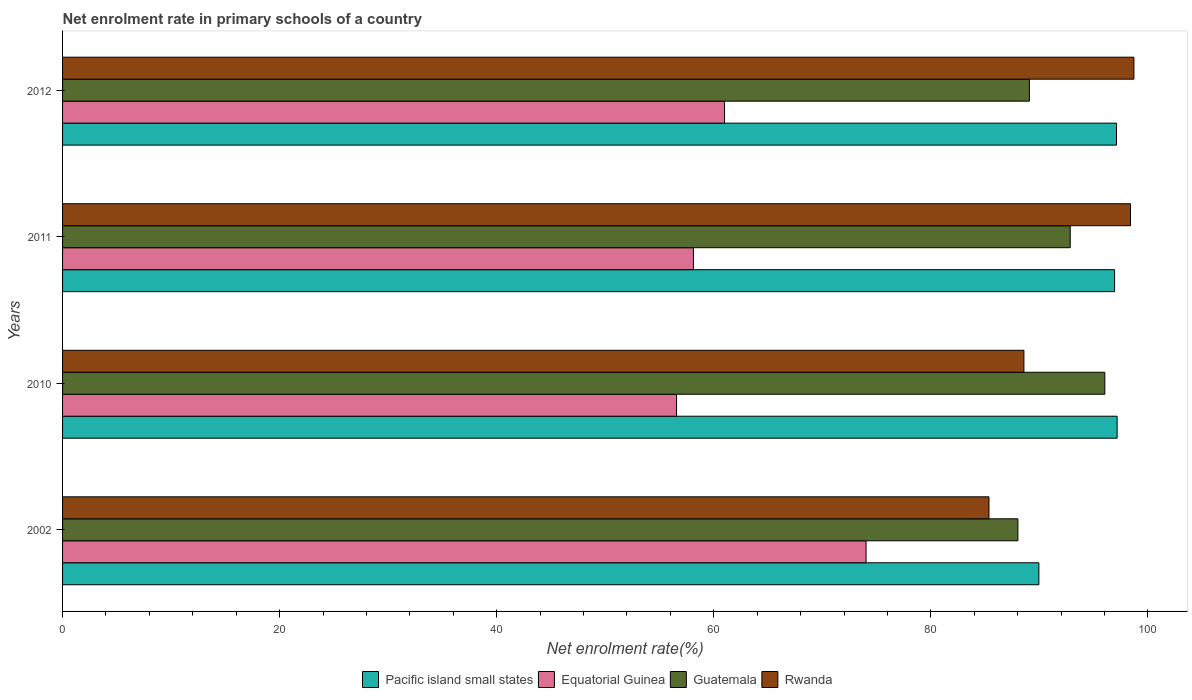How many different coloured bars are there?
Ensure brevity in your answer.  4. How many groups of bars are there?
Make the answer very short. 4. Are the number of bars per tick equal to the number of legend labels?
Your answer should be very brief. Yes. Are the number of bars on each tick of the Y-axis equal?
Your answer should be very brief. Yes. How many bars are there on the 4th tick from the bottom?
Provide a succinct answer. 4. What is the net enrolment rate in primary schools in Equatorial Guinea in 2010?
Keep it short and to the point. 56.57. Across all years, what is the maximum net enrolment rate in primary schools in Rwanda?
Give a very brief answer. 98.71. Across all years, what is the minimum net enrolment rate in primary schools in Pacific island small states?
Offer a terse response. 89.95. In which year was the net enrolment rate in primary schools in Equatorial Guinea maximum?
Offer a very short reply. 2002. What is the total net enrolment rate in primary schools in Pacific island small states in the graph?
Make the answer very short. 381.14. What is the difference between the net enrolment rate in primary schools in Pacific island small states in 2010 and that in 2012?
Offer a terse response. 0.06. What is the difference between the net enrolment rate in primary schools in Equatorial Guinea in 2010 and the net enrolment rate in primary schools in Rwanda in 2012?
Ensure brevity in your answer.  -42.14. What is the average net enrolment rate in primary schools in Rwanda per year?
Provide a succinct answer. 92.76. In the year 2002, what is the difference between the net enrolment rate in primary schools in Pacific island small states and net enrolment rate in primary schools in Guatemala?
Keep it short and to the point. 1.93. What is the ratio of the net enrolment rate in primary schools in Equatorial Guinea in 2002 to that in 2010?
Offer a very short reply. 1.31. Is the net enrolment rate in primary schools in Pacific island small states in 2011 less than that in 2012?
Ensure brevity in your answer.  Yes. What is the difference between the highest and the second highest net enrolment rate in primary schools in Rwanda?
Keep it short and to the point. 0.31. What is the difference between the highest and the lowest net enrolment rate in primary schools in Equatorial Guinea?
Offer a very short reply. 17.46. In how many years, is the net enrolment rate in primary schools in Equatorial Guinea greater than the average net enrolment rate in primary schools in Equatorial Guinea taken over all years?
Make the answer very short. 1. Is the sum of the net enrolment rate in primary schools in Guatemala in 2011 and 2012 greater than the maximum net enrolment rate in primary schools in Equatorial Guinea across all years?
Your answer should be very brief. Yes. What does the 4th bar from the top in 2010 represents?
Ensure brevity in your answer.  Pacific island small states. What does the 4th bar from the bottom in 2010 represents?
Offer a terse response. Rwanda. Is it the case that in every year, the sum of the net enrolment rate in primary schools in Equatorial Guinea and net enrolment rate in primary schools in Pacific island small states is greater than the net enrolment rate in primary schools in Guatemala?
Keep it short and to the point. Yes. How many bars are there?
Provide a short and direct response. 16. Are all the bars in the graph horizontal?
Provide a succinct answer. Yes. How many years are there in the graph?
Provide a succinct answer. 4. What is the difference between two consecutive major ticks on the X-axis?
Your response must be concise. 20. Where does the legend appear in the graph?
Offer a very short reply. Bottom center. How are the legend labels stacked?
Make the answer very short. Horizontal. What is the title of the graph?
Offer a very short reply. Net enrolment rate in primary schools of a country. What is the label or title of the X-axis?
Your answer should be very brief. Net enrolment rate(%). What is the Net enrolment rate(%) in Pacific island small states in 2002?
Your response must be concise. 89.95. What is the Net enrolment rate(%) of Equatorial Guinea in 2002?
Your response must be concise. 74.03. What is the Net enrolment rate(%) of Guatemala in 2002?
Give a very brief answer. 88.02. What is the Net enrolment rate(%) of Rwanda in 2002?
Your response must be concise. 85.35. What is the Net enrolment rate(%) of Pacific island small states in 2010?
Ensure brevity in your answer.  97.16. What is the Net enrolment rate(%) in Equatorial Guinea in 2010?
Your answer should be very brief. 56.57. What is the Net enrolment rate(%) in Guatemala in 2010?
Keep it short and to the point. 96.03. What is the Net enrolment rate(%) of Rwanda in 2010?
Your answer should be very brief. 88.57. What is the Net enrolment rate(%) of Pacific island small states in 2011?
Keep it short and to the point. 96.93. What is the Net enrolment rate(%) in Equatorial Guinea in 2011?
Provide a short and direct response. 58.12. What is the Net enrolment rate(%) in Guatemala in 2011?
Give a very brief answer. 92.84. What is the Net enrolment rate(%) of Rwanda in 2011?
Make the answer very short. 98.39. What is the Net enrolment rate(%) of Pacific island small states in 2012?
Offer a terse response. 97.1. What is the Net enrolment rate(%) of Equatorial Guinea in 2012?
Ensure brevity in your answer.  60.99. What is the Net enrolment rate(%) in Guatemala in 2012?
Offer a very short reply. 89.08. What is the Net enrolment rate(%) of Rwanda in 2012?
Your answer should be compact. 98.71. Across all years, what is the maximum Net enrolment rate(%) in Pacific island small states?
Make the answer very short. 97.16. Across all years, what is the maximum Net enrolment rate(%) of Equatorial Guinea?
Provide a short and direct response. 74.03. Across all years, what is the maximum Net enrolment rate(%) of Guatemala?
Offer a terse response. 96.03. Across all years, what is the maximum Net enrolment rate(%) of Rwanda?
Your answer should be very brief. 98.71. Across all years, what is the minimum Net enrolment rate(%) in Pacific island small states?
Your answer should be very brief. 89.95. Across all years, what is the minimum Net enrolment rate(%) of Equatorial Guinea?
Offer a terse response. 56.57. Across all years, what is the minimum Net enrolment rate(%) of Guatemala?
Offer a terse response. 88.02. Across all years, what is the minimum Net enrolment rate(%) in Rwanda?
Provide a short and direct response. 85.35. What is the total Net enrolment rate(%) in Pacific island small states in the graph?
Offer a very short reply. 381.14. What is the total Net enrolment rate(%) in Equatorial Guinea in the graph?
Provide a succinct answer. 249.71. What is the total Net enrolment rate(%) of Guatemala in the graph?
Offer a very short reply. 365.96. What is the total Net enrolment rate(%) of Rwanda in the graph?
Ensure brevity in your answer.  371.03. What is the difference between the Net enrolment rate(%) of Pacific island small states in 2002 and that in 2010?
Keep it short and to the point. -7.21. What is the difference between the Net enrolment rate(%) of Equatorial Guinea in 2002 and that in 2010?
Provide a short and direct response. 17.46. What is the difference between the Net enrolment rate(%) in Guatemala in 2002 and that in 2010?
Your answer should be very brief. -8.01. What is the difference between the Net enrolment rate(%) of Rwanda in 2002 and that in 2010?
Offer a terse response. -3.22. What is the difference between the Net enrolment rate(%) of Pacific island small states in 2002 and that in 2011?
Your answer should be compact. -6.98. What is the difference between the Net enrolment rate(%) in Equatorial Guinea in 2002 and that in 2011?
Give a very brief answer. 15.91. What is the difference between the Net enrolment rate(%) in Guatemala in 2002 and that in 2011?
Your answer should be very brief. -4.82. What is the difference between the Net enrolment rate(%) of Rwanda in 2002 and that in 2011?
Keep it short and to the point. -13.04. What is the difference between the Net enrolment rate(%) in Pacific island small states in 2002 and that in 2012?
Provide a succinct answer. -7.15. What is the difference between the Net enrolment rate(%) in Equatorial Guinea in 2002 and that in 2012?
Your response must be concise. 13.04. What is the difference between the Net enrolment rate(%) of Guatemala in 2002 and that in 2012?
Offer a very short reply. -1.06. What is the difference between the Net enrolment rate(%) in Rwanda in 2002 and that in 2012?
Your response must be concise. -13.35. What is the difference between the Net enrolment rate(%) in Pacific island small states in 2010 and that in 2011?
Make the answer very short. 0.23. What is the difference between the Net enrolment rate(%) of Equatorial Guinea in 2010 and that in 2011?
Provide a succinct answer. -1.55. What is the difference between the Net enrolment rate(%) in Guatemala in 2010 and that in 2011?
Offer a very short reply. 3.19. What is the difference between the Net enrolment rate(%) of Rwanda in 2010 and that in 2011?
Give a very brief answer. -9.82. What is the difference between the Net enrolment rate(%) of Pacific island small states in 2010 and that in 2012?
Provide a succinct answer. 0.06. What is the difference between the Net enrolment rate(%) in Equatorial Guinea in 2010 and that in 2012?
Ensure brevity in your answer.  -4.42. What is the difference between the Net enrolment rate(%) of Guatemala in 2010 and that in 2012?
Your answer should be very brief. 6.95. What is the difference between the Net enrolment rate(%) in Rwanda in 2010 and that in 2012?
Keep it short and to the point. -10.14. What is the difference between the Net enrolment rate(%) in Pacific island small states in 2011 and that in 2012?
Your answer should be compact. -0.18. What is the difference between the Net enrolment rate(%) in Equatorial Guinea in 2011 and that in 2012?
Offer a very short reply. -2.87. What is the difference between the Net enrolment rate(%) of Guatemala in 2011 and that in 2012?
Make the answer very short. 3.76. What is the difference between the Net enrolment rate(%) in Rwanda in 2011 and that in 2012?
Your answer should be very brief. -0.31. What is the difference between the Net enrolment rate(%) of Pacific island small states in 2002 and the Net enrolment rate(%) of Equatorial Guinea in 2010?
Your response must be concise. 33.38. What is the difference between the Net enrolment rate(%) in Pacific island small states in 2002 and the Net enrolment rate(%) in Guatemala in 2010?
Provide a short and direct response. -6.07. What is the difference between the Net enrolment rate(%) in Pacific island small states in 2002 and the Net enrolment rate(%) in Rwanda in 2010?
Ensure brevity in your answer.  1.38. What is the difference between the Net enrolment rate(%) in Equatorial Guinea in 2002 and the Net enrolment rate(%) in Guatemala in 2010?
Provide a succinct answer. -22. What is the difference between the Net enrolment rate(%) in Equatorial Guinea in 2002 and the Net enrolment rate(%) in Rwanda in 2010?
Make the answer very short. -14.54. What is the difference between the Net enrolment rate(%) in Guatemala in 2002 and the Net enrolment rate(%) in Rwanda in 2010?
Make the answer very short. -0.55. What is the difference between the Net enrolment rate(%) in Pacific island small states in 2002 and the Net enrolment rate(%) in Equatorial Guinea in 2011?
Your answer should be compact. 31.83. What is the difference between the Net enrolment rate(%) in Pacific island small states in 2002 and the Net enrolment rate(%) in Guatemala in 2011?
Your response must be concise. -2.89. What is the difference between the Net enrolment rate(%) of Pacific island small states in 2002 and the Net enrolment rate(%) of Rwanda in 2011?
Provide a short and direct response. -8.44. What is the difference between the Net enrolment rate(%) of Equatorial Guinea in 2002 and the Net enrolment rate(%) of Guatemala in 2011?
Offer a very short reply. -18.81. What is the difference between the Net enrolment rate(%) of Equatorial Guinea in 2002 and the Net enrolment rate(%) of Rwanda in 2011?
Your answer should be compact. -24.36. What is the difference between the Net enrolment rate(%) in Guatemala in 2002 and the Net enrolment rate(%) in Rwanda in 2011?
Your answer should be very brief. -10.38. What is the difference between the Net enrolment rate(%) in Pacific island small states in 2002 and the Net enrolment rate(%) in Equatorial Guinea in 2012?
Ensure brevity in your answer.  28.96. What is the difference between the Net enrolment rate(%) of Pacific island small states in 2002 and the Net enrolment rate(%) of Guatemala in 2012?
Offer a terse response. 0.87. What is the difference between the Net enrolment rate(%) in Pacific island small states in 2002 and the Net enrolment rate(%) in Rwanda in 2012?
Your answer should be very brief. -8.76. What is the difference between the Net enrolment rate(%) in Equatorial Guinea in 2002 and the Net enrolment rate(%) in Guatemala in 2012?
Make the answer very short. -15.05. What is the difference between the Net enrolment rate(%) in Equatorial Guinea in 2002 and the Net enrolment rate(%) in Rwanda in 2012?
Your answer should be very brief. -24.68. What is the difference between the Net enrolment rate(%) in Guatemala in 2002 and the Net enrolment rate(%) in Rwanda in 2012?
Your response must be concise. -10.69. What is the difference between the Net enrolment rate(%) in Pacific island small states in 2010 and the Net enrolment rate(%) in Equatorial Guinea in 2011?
Offer a very short reply. 39.04. What is the difference between the Net enrolment rate(%) in Pacific island small states in 2010 and the Net enrolment rate(%) in Guatemala in 2011?
Offer a very short reply. 4.32. What is the difference between the Net enrolment rate(%) of Pacific island small states in 2010 and the Net enrolment rate(%) of Rwanda in 2011?
Give a very brief answer. -1.23. What is the difference between the Net enrolment rate(%) in Equatorial Guinea in 2010 and the Net enrolment rate(%) in Guatemala in 2011?
Your answer should be compact. -36.27. What is the difference between the Net enrolment rate(%) in Equatorial Guinea in 2010 and the Net enrolment rate(%) in Rwanda in 2011?
Keep it short and to the point. -41.83. What is the difference between the Net enrolment rate(%) in Guatemala in 2010 and the Net enrolment rate(%) in Rwanda in 2011?
Your answer should be compact. -2.37. What is the difference between the Net enrolment rate(%) in Pacific island small states in 2010 and the Net enrolment rate(%) in Equatorial Guinea in 2012?
Ensure brevity in your answer.  36.17. What is the difference between the Net enrolment rate(%) in Pacific island small states in 2010 and the Net enrolment rate(%) in Guatemala in 2012?
Offer a very short reply. 8.08. What is the difference between the Net enrolment rate(%) in Pacific island small states in 2010 and the Net enrolment rate(%) in Rwanda in 2012?
Your answer should be very brief. -1.55. What is the difference between the Net enrolment rate(%) in Equatorial Guinea in 2010 and the Net enrolment rate(%) in Guatemala in 2012?
Your response must be concise. -32.51. What is the difference between the Net enrolment rate(%) in Equatorial Guinea in 2010 and the Net enrolment rate(%) in Rwanda in 2012?
Make the answer very short. -42.14. What is the difference between the Net enrolment rate(%) in Guatemala in 2010 and the Net enrolment rate(%) in Rwanda in 2012?
Your response must be concise. -2.68. What is the difference between the Net enrolment rate(%) in Pacific island small states in 2011 and the Net enrolment rate(%) in Equatorial Guinea in 2012?
Keep it short and to the point. 35.94. What is the difference between the Net enrolment rate(%) in Pacific island small states in 2011 and the Net enrolment rate(%) in Guatemala in 2012?
Make the answer very short. 7.85. What is the difference between the Net enrolment rate(%) in Pacific island small states in 2011 and the Net enrolment rate(%) in Rwanda in 2012?
Your response must be concise. -1.78. What is the difference between the Net enrolment rate(%) of Equatorial Guinea in 2011 and the Net enrolment rate(%) of Guatemala in 2012?
Keep it short and to the point. -30.96. What is the difference between the Net enrolment rate(%) in Equatorial Guinea in 2011 and the Net enrolment rate(%) in Rwanda in 2012?
Keep it short and to the point. -40.59. What is the difference between the Net enrolment rate(%) of Guatemala in 2011 and the Net enrolment rate(%) of Rwanda in 2012?
Keep it short and to the point. -5.87. What is the average Net enrolment rate(%) in Pacific island small states per year?
Keep it short and to the point. 95.29. What is the average Net enrolment rate(%) of Equatorial Guinea per year?
Give a very brief answer. 62.43. What is the average Net enrolment rate(%) in Guatemala per year?
Make the answer very short. 91.49. What is the average Net enrolment rate(%) of Rwanda per year?
Your answer should be very brief. 92.76. In the year 2002, what is the difference between the Net enrolment rate(%) in Pacific island small states and Net enrolment rate(%) in Equatorial Guinea?
Offer a terse response. 15.92. In the year 2002, what is the difference between the Net enrolment rate(%) of Pacific island small states and Net enrolment rate(%) of Guatemala?
Your answer should be compact. 1.93. In the year 2002, what is the difference between the Net enrolment rate(%) of Pacific island small states and Net enrolment rate(%) of Rwanda?
Make the answer very short. 4.6. In the year 2002, what is the difference between the Net enrolment rate(%) in Equatorial Guinea and Net enrolment rate(%) in Guatemala?
Provide a short and direct response. -13.99. In the year 2002, what is the difference between the Net enrolment rate(%) in Equatorial Guinea and Net enrolment rate(%) in Rwanda?
Offer a terse response. -11.32. In the year 2002, what is the difference between the Net enrolment rate(%) in Guatemala and Net enrolment rate(%) in Rwanda?
Make the answer very short. 2.66. In the year 2010, what is the difference between the Net enrolment rate(%) in Pacific island small states and Net enrolment rate(%) in Equatorial Guinea?
Offer a terse response. 40.59. In the year 2010, what is the difference between the Net enrolment rate(%) of Pacific island small states and Net enrolment rate(%) of Guatemala?
Your answer should be very brief. 1.13. In the year 2010, what is the difference between the Net enrolment rate(%) of Pacific island small states and Net enrolment rate(%) of Rwanda?
Give a very brief answer. 8.59. In the year 2010, what is the difference between the Net enrolment rate(%) in Equatorial Guinea and Net enrolment rate(%) in Guatemala?
Offer a terse response. -39.46. In the year 2010, what is the difference between the Net enrolment rate(%) of Equatorial Guinea and Net enrolment rate(%) of Rwanda?
Provide a succinct answer. -32. In the year 2010, what is the difference between the Net enrolment rate(%) in Guatemala and Net enrolment rate(%) in Rwanda?
Ensure brevity in your answer.  7.45. In the year 2011, what is the difference between the Net enrolment rate(%) in Pacific island small states and Net enrolment rate(%) in Equatorial Guinea?
Make the answer very short. 38.81. In the year 2011, what is the difference between the Net enrolment rate(%) of Pacific island small states and Net enrolment rate(%) of Guatemala?
Your response must be concise. 4.09. In the year 2011, what is the difference between the Net enrolment rate(%) of Pacific island small states and Net enrolment rate(%) of Rwanda?
Make the answer very short. -1.47. In the year 2011, what is the difference between the Net enrolment rate(%) in Equatorial Guinea and Net enrolment rate(%) in Guatemala?
Ensure brevity in your answer.  -34.72. In the year 2011, what is the difference between the Net enrolment rate(%) in Equatorial Guinea and Net enrolment rate(%) in Rwanda?
Provide a short and direct response. -40.27. In the year 2011, what is the difference between the Net enrolment rate(%) of Guatemala and Net enrolment rate(%) of Rwanda?
Make the answer very short. -5.55. In the year 2012, what is the difference between the Net enrolment rate(%) in Pacific island small states and Net enrolment rate(%) in Equatorial Guinea?
Your response must be concise. 36.11. In the year 2012, what is the difference between the Net enrolment rate(%) in Pacific island small states and Net enrolment rate(%) in Guatemala?
Your answer should be compact. 8.03. In the year 2012, what is the difference between the Net enrolment rate(%) in Pacific island small states and Net enrolment rate(%) in Rwanda?
Offer a terse response. -1.61. In the year 2012, what is the difference between the Net enrolment rate(%) of Equatorial Guinea and Net enrolment rate(%) of Guatemala?
Provide a succinct answer. -28.09. In the year 2012, what is the difference between the Net enrolment rate(%) in Equatorial Guinea and Net enrolment rate(%) in Rwanda?
Your response must be concise. -37.72. In the year 2012, what is the difference between the Net enrolment rate(%) in Guatemala and Net enrolment rate(%) in Rwanda?
Offer a very short reply. -9.63. What is the ratio of the Net enrolment rate(%) in Pacific island small states in 2002 to that in 2010?
Ensure brevity in your answer.  0.93. What is the ratio of the Net enrolment rate(%) of Equatorial Guinea in 2002 to that in 2010?
Ensure brevity in your answer.  1.31. What is the ratio of the Net enrolment rate(%) in Guatemala in 2002 to that in 2010?
Offer a terse response. 0.92. What is the ratio of the Net enrolment rate(%) in Rwanda in 2002 to that in 2010?
Keep it short and to the point. 0.96. What is the ratio of the Net enrolment rate(%) of Pacific island small states in 2002 to that in 2011?
Offer a terse response. 0.93. What is the ratio of the Net enrolment rate(%) in Equatorial Guinea in 2002 to that in 2011?
Provide a short and direct response. 1.27. What is the ratio of the Net enrolment rate(%) in Guatemala in 2002 to that in 2011?
Provide a succinct answer. 0.95. What is the ratio of the Net enrolment rate(%) in Rwanda in 2002 to that in 2011?
Offer a very short reply. 0.87. What is the ratio of the Net enrolment rate(%) in Pacific island small states in 2002 to that in 2012?
Make the answer very short. 0.93. What is the ratio of the Net enrolment rate(%) in Equatorial Guinea in 2002 to that in 2012?
Offer a very short reply. 1.21. What is the ratio of the Net enrolment rate(%) in Guatemala in 2002 to that in 2012?
Provide a succinct answer. 0.99. What is the ratio of the Net enrolment rate(%) in Rwanda in 2002 to that in 2012?
Ensure brevity in your answer.  0.86. What is the ratio of the Net enrolment rate(%) of Pacific island small states in 2010 to that in 2011?
Your answer should be compact. 1. What is the ratio of the Net enrolment rate(%) in Equatorial Guinea in 2010 to that in 2011?
Make the answer very short. 0.97. What is the ratio of the Net enrolment rate(%) of Guatemala in 2010 to that in 2011?
Your answer should be compact. 1.03. What is the ratio of the Net enrolment rate(%) of Rwanda in 2010 to that in 2011?
Your answer should be very brief. 0.9. What is the ratio of the Net enrolment rate(%) of Equatorial Guinea in 2010 to that in 2012?
Give a very brief answer. 0.93. What is the ratio of the Net enrolment rate(%) of Guatemala in 2010 to that in 2012?
Offer a very short reply. 1.08. What is the ratio of the Net enrolment rate(%) in Rwanda in 2010 to that in 2012?
Offer a very short reply. 0.9. What is the ratio of the Net enrolment rate(%) in Pacific island small states in 2011 to that in 2012?
Provide a short and direct response. 1. What is the ratio of the Net enrolment rate(%) in Equatorial Guinea in 2011 to that in 2012?
Make the answer very short. 0.95. What is the ratio of the Net enrolment rate(%) of Guatemala in 2011 to that in 2012?
Ensure brevity in your answer.  1.04. What is the ratio of the Net enrolment rate(%) in Rwanda in 2011 to that in 2012?
Give a very brief answer. 1. What is the difference between the highest and the second highest Net enrolment rate(%) of Pacific island small states?
Your answer should be compact. 0.06. What is the difference between the highest and the second highest Net enrolment rate(%) of Equatorial Guinea?
Give a very brief answer. 13.04. What is the difference between the highest and the second highest Net enrolment rate(%) of Guatemala?
Your answer should be very brief. 3.19. What is the difference between the highest and the second highest Net enrolment rate(%) in Rwanda?
Provide a short and direct response. 0.31. What is the difference between the highest and the lowest Net enrolment rate(%) of Pacific island small states?
Give a very brief answer. 7.21. What is the difference between the highest and the lowest Net enrolment rate(%) of Equatorial Guinea?
Provide a short and direct response. 17.46. What is the difference between the highest and the lowest Net enrolment rate(%) of Guatemala?
Keep it short and to the point. 8.01. What is the difference between the highest and the lowest Net enrolment rate(%) of Rwanda?
Your answer should be compact. 13.35. 